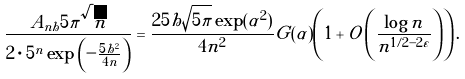<formula> <loc_0><loc_0><loc_500><loc_500>\frac { A _ { n h } 5 \pi \sqrt { n } } { 2 \cdot 5 ^ { n } \exp \left ( - \frac { 5 h ^ { 2 } } { 4 n } \right ) } = \frac { 2 5 h \sqrt { 5 \pi } \exp ( \alpha ^ { 2 } ) } { 4 n ^ { 2 } } G ( \alpha ) \left ( 1 + O \left ( \frac { \log n } { n ^ { 1 / 2 - 2 \varepsilon } } \right ) \right ) .</formula> 